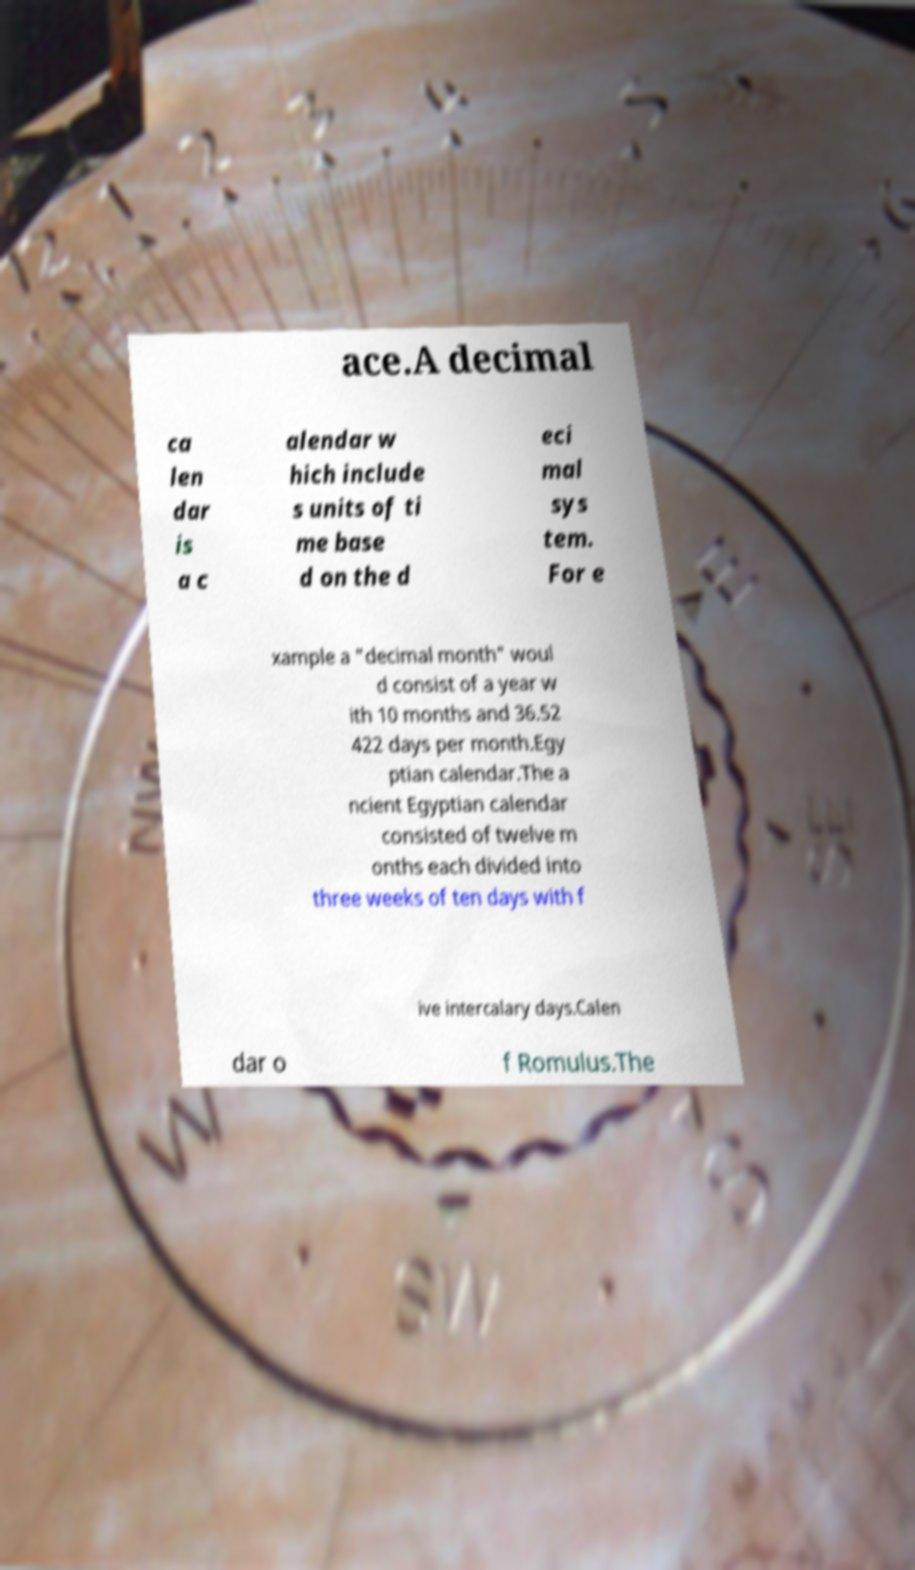Can you accurately transcribe the text from the provided image for me? ace.A decimal ca len dar is a c alendar w hich include s units of ti me base d on the d eci mal sys tem. For e xample a "decimal month" woul d consist of a year w ith 10 months and 36.52 422 days per month.Egy ptian calendar.The a ncient Egyptian calendar consisted of twelve m onths each divided into three weeks of ten days with f ive intercalary days.Calen dar o f Romulus.The 